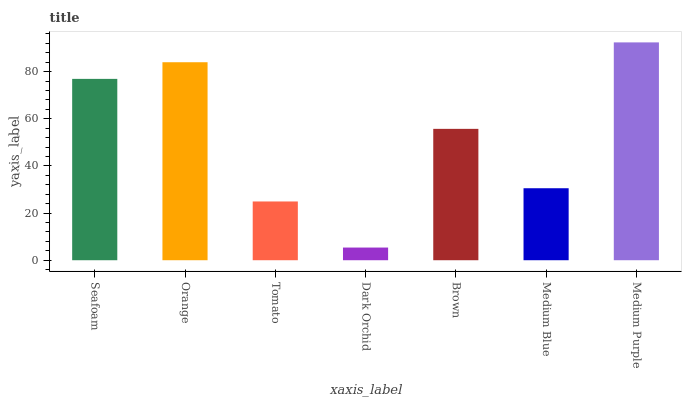Is Dark Orchid the minimum?
Answer yes or no. Yes. Is Medium Purple the maximum?
Answer yes or no. Yes. Is Orange the minimum?
Answer yes or no. No. Is Orange the maximum?
Answer yes or no. No. Is Orange greater than Seafoam?
Answer yes or no. Yes. Is Seafoam less than Orange?
Answer yes or no. Yes. Is Seafoam greater than Orange?
Answer yes or no. No. Is Orange less than Seafoam?
Answer yes or no. No. Is Brown the high median?
Answer yes or no. Yes. Is Brown the low median?
Answer yes or no. Yes. Is Medium Purple the high median?
Answer yes or no. No. Is Tomato the low median?
Answer yes or no. No. 